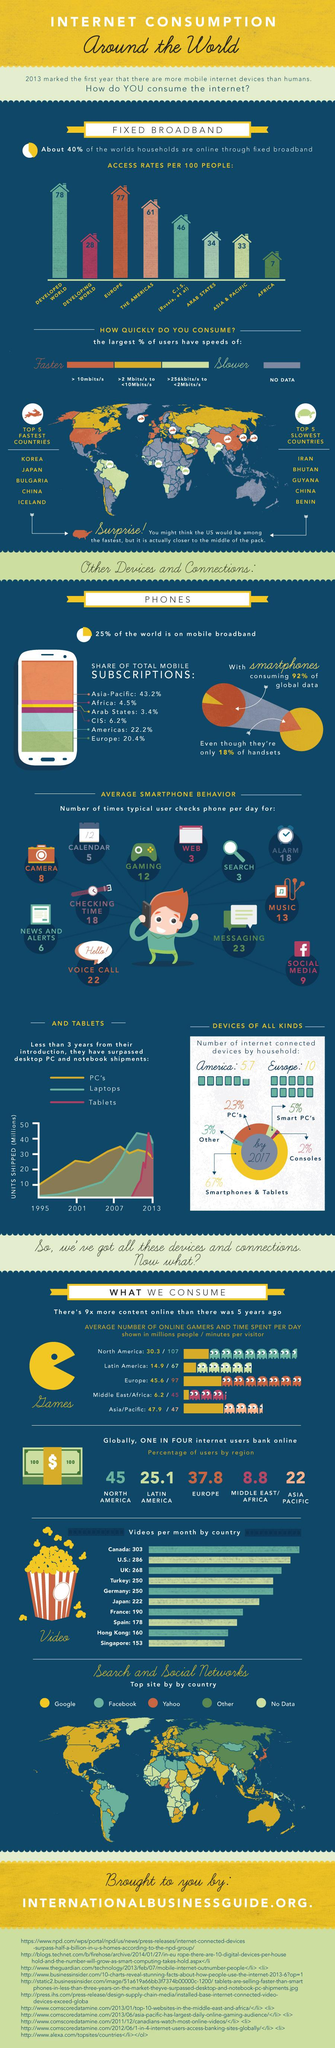Give some essential details in this illustration. The number of internet-connected devices per household in America and Europe, when combined, is approximately 15.7. A typical user checks their phone 18 times per day to set an alarm. A significant percentage of the world's population does not have access to mobile broadband. A typical user checks their phone 13 times per day to access music. The total number of mobile subscriptions in the Americas and Europe together is 42.6%. 